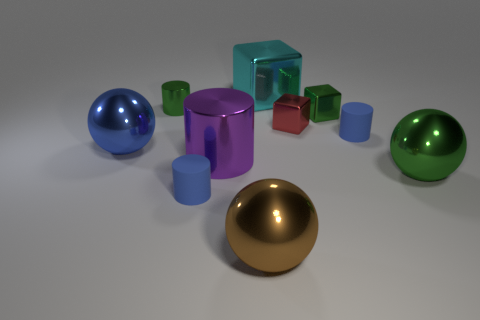Is the material of the tiny green object to the right of the big purple cylinder the same as the large thing to the left of the green cylinder?
Give a very brief answer. Yes. Are there the same number of small objects in front of the tiny green cube and brown things to the left of the large blue sphere?
Offer a terse response. No. What color is the cylinder that is the same size as the brown ball?
Keep it short and to the point. Purple. Is there a rubber object that has the same color as the large cylinder?
Your response must be concise. No. What number of objects are either big things that are left of the brown ball or brown metal things?
Offer a very short reply. 3. How many other things are the same size as the purple cylinder?
Make the answer very short. 4. What is the tiny blue cylinder to the left of the cyan metal cube behind the blue matte cylinder that is on the right side of the brown thing made of?
Provide a succinct answer. Rubber. How many balls are big brown objects or purple metal objects?
Your answer should be very brief. 1. Are there any other things that have the same shape as the cyan object?
Ensure brevity in your answer.  Yes. Is the number of large green things that are right of the red cube greater than the number of big shiny balls that are behind the big blue sphere?
Your answer should be very brief. Yes. 